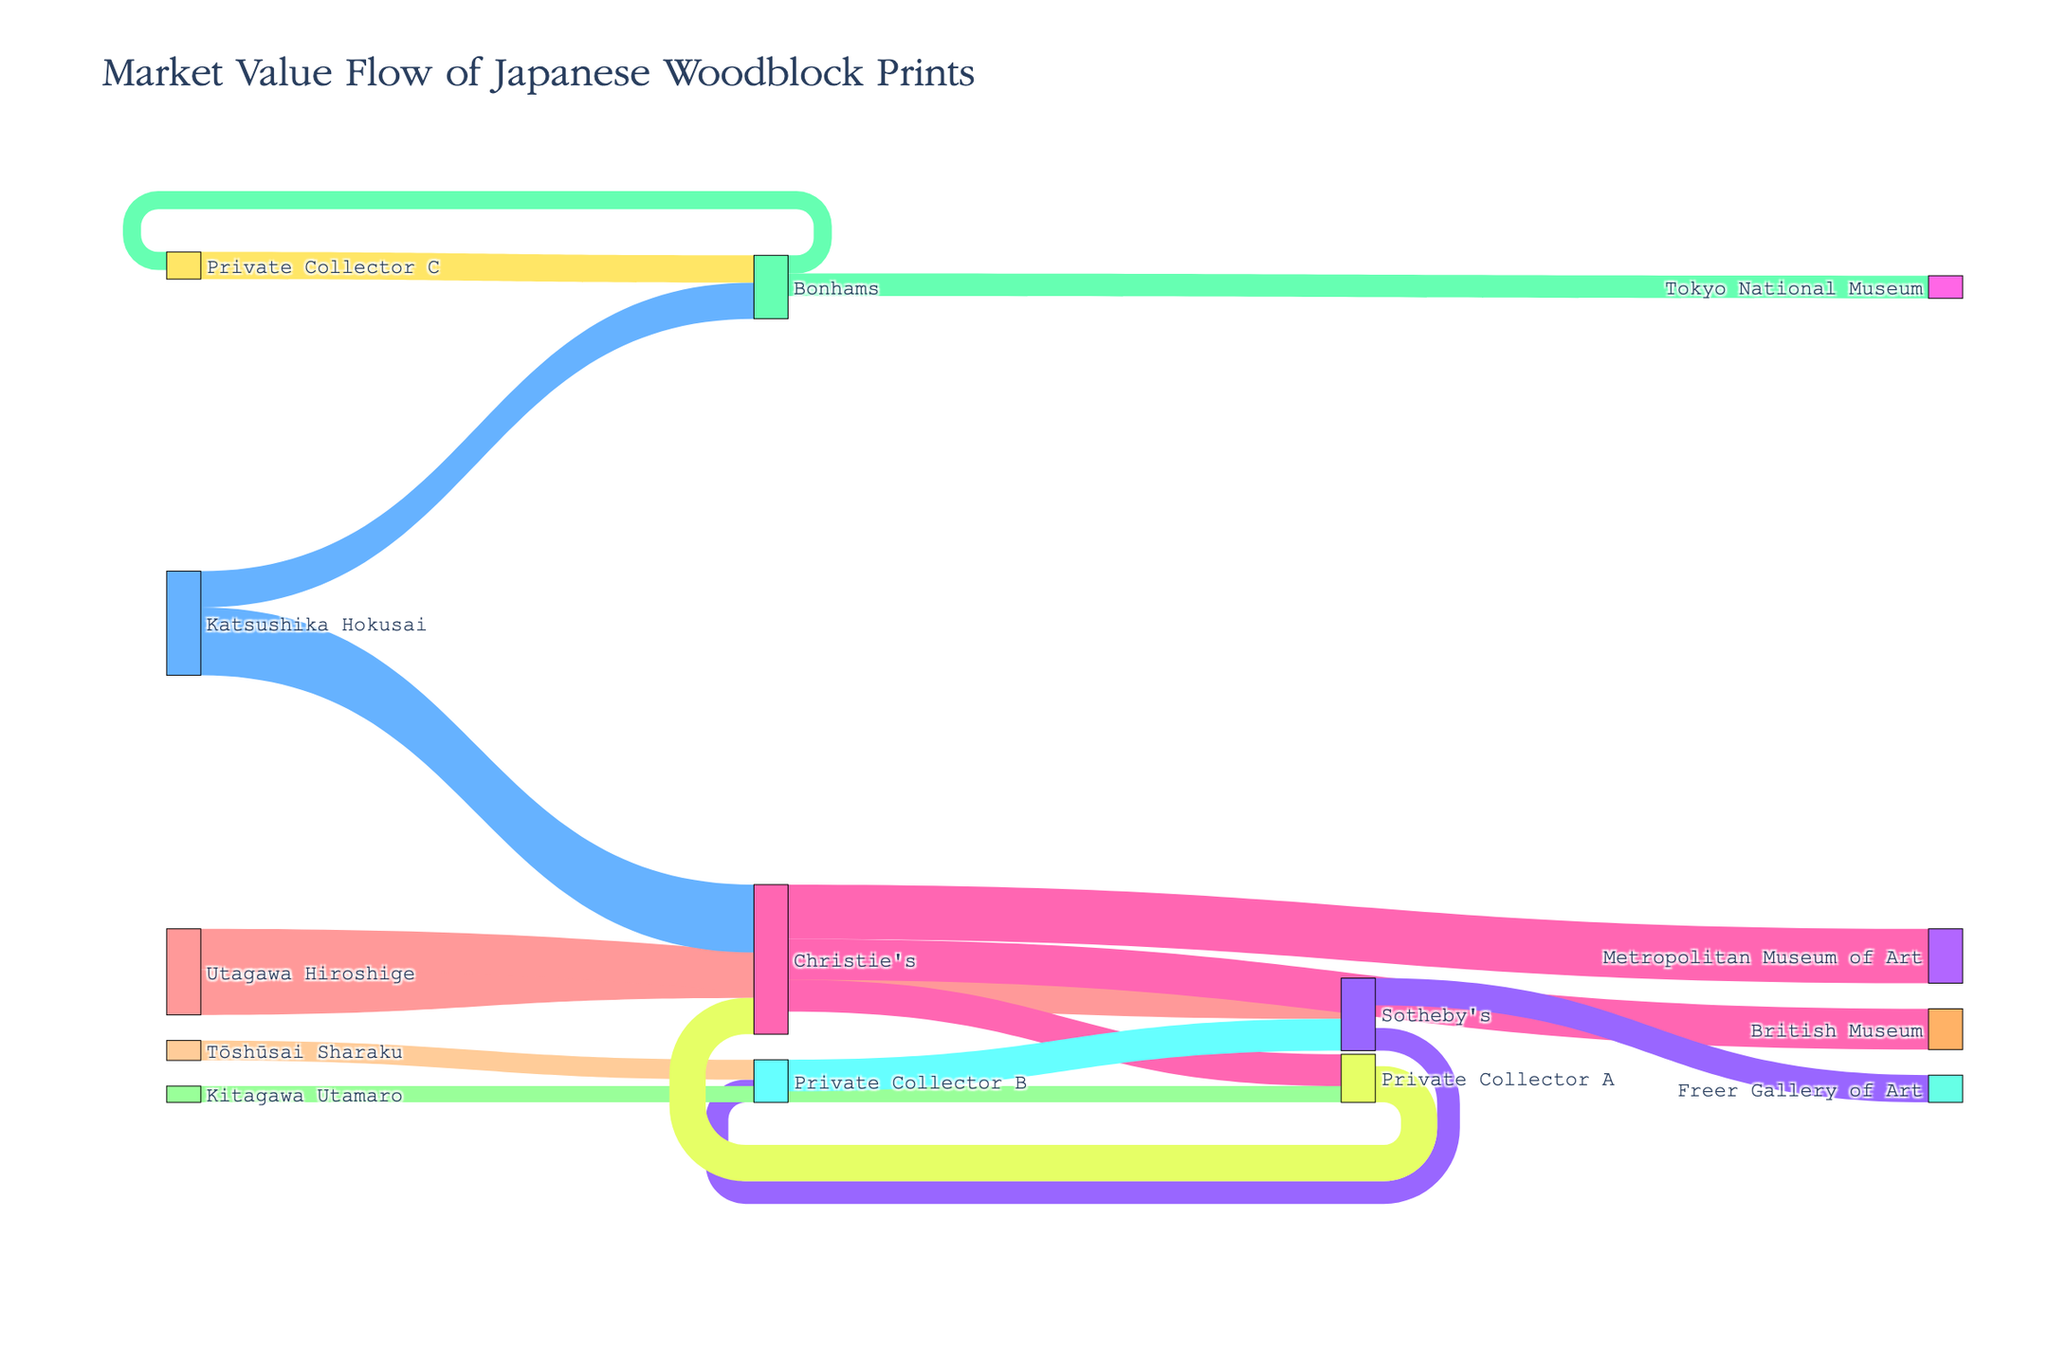What is the title of the Sankey Diagram? The title is located at the top of the diagram and serves as the overall descriptor of the visual information presented.
Answer: Market Value Flow of Japanese Woodblock Prints Which artist has the highest total market value flowing to auction houses? By summing up the values flowing from each artist to auction houses, one can see the totals. Katsushika Hokusai has values of 750,000 to Christie's and 400,000 to Bonhams, totaling to 1,150,000.
Answer: Katsushika Hokusai What is the total market value flowing to Christie's from all sources? Adding all values flowing into Christie's from different sources would give the total: Utagawa Hiroshige (500,000), Katsushika Hokusai (750,000), and Private Collector A (400,000) sum up to 1,650,000.
Answer: 1,650,000 Which auction house has the highest total value from Private Collectors? By summing the values flowing from Private Collector A, B, and C to auction houses, we see that Christie's receives 400,000 from Private Collector A, Sotheby's receives 350,000 from Private Collector B, and Bonhams receives 300,000 from Private Collector C. Christie's has the highest with 400,000.
Answer: Christie's How much market value flows from Sotheby's to the Freer Gallery of Art and Private Collector B combined? Summing the values flowing from Sotheby's to the Freer Gallery of Art (300,000) and Private Collector B (250,000) gives a total of 550,000.
Answer: 550,000 Which museum receives the largest market value from Christie's, and what is that value? By comparing the values from Christie's to different museums, the Metropolitan Museum of Art receives 600,000, which is the largest value.
Answer: Metropolitan Museum of Art, 600,000 How much market value flows directly from auction houses to museums? Adding the values from Christie's, Sotheby's, and Bonhams to museums: Christie's to Metropolitan Museum of Art (600,000) and British Museum (450,000), Sotheby's to Freer Gallery of Art (300,000), Bonhams to Tokyo National Museum (250,000) total is 1,600,000.
Answer: 1,600,000 What is the difference in market value between the flows from Utagawa Hiroshige to Christie's and Sotheby's? Subtracting the value from Utagawa Hiroshige to Sotheby's (450,000) from the value to Christie's (500,000) gives a difference of 50,000.
Answer: 50,000 Which entity acts as both a source and a target in the Sankey Diagram? By examining all labels, Private Collector A appears as both a source and a target, receiving from artists and selling to Christie's.
Answer: Private Collector A 